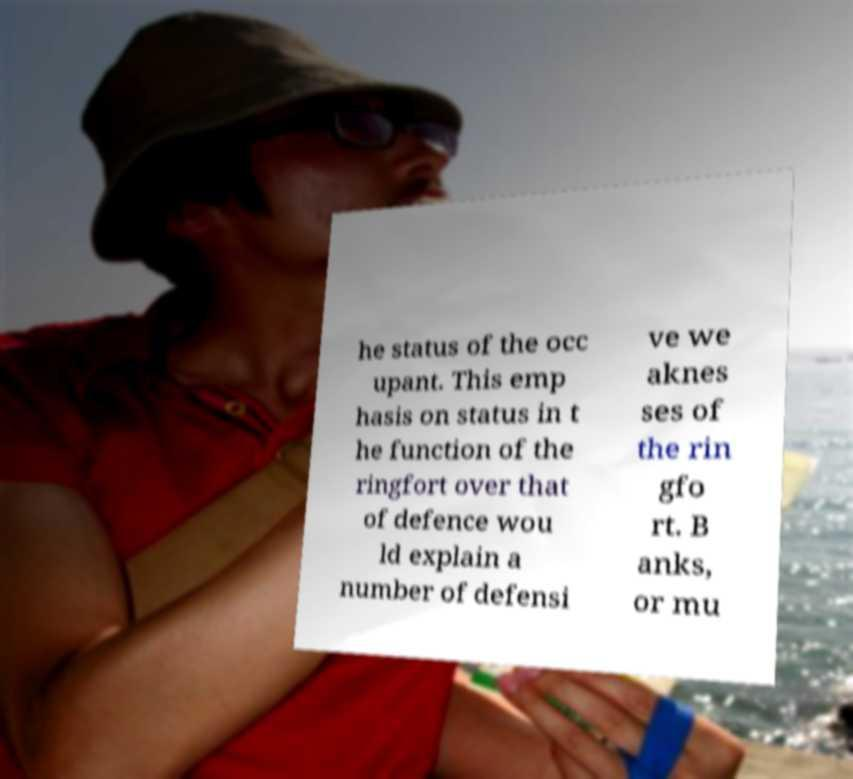What messages or text are displayed in this image? I need them in a readable, typed format. he status of the occ upant. This emp hasis on status in t he function of the ringfort over that of defence wou ld explain a number of defensi ve we aknes ses of the rin gfo rt. B anks, or mu 